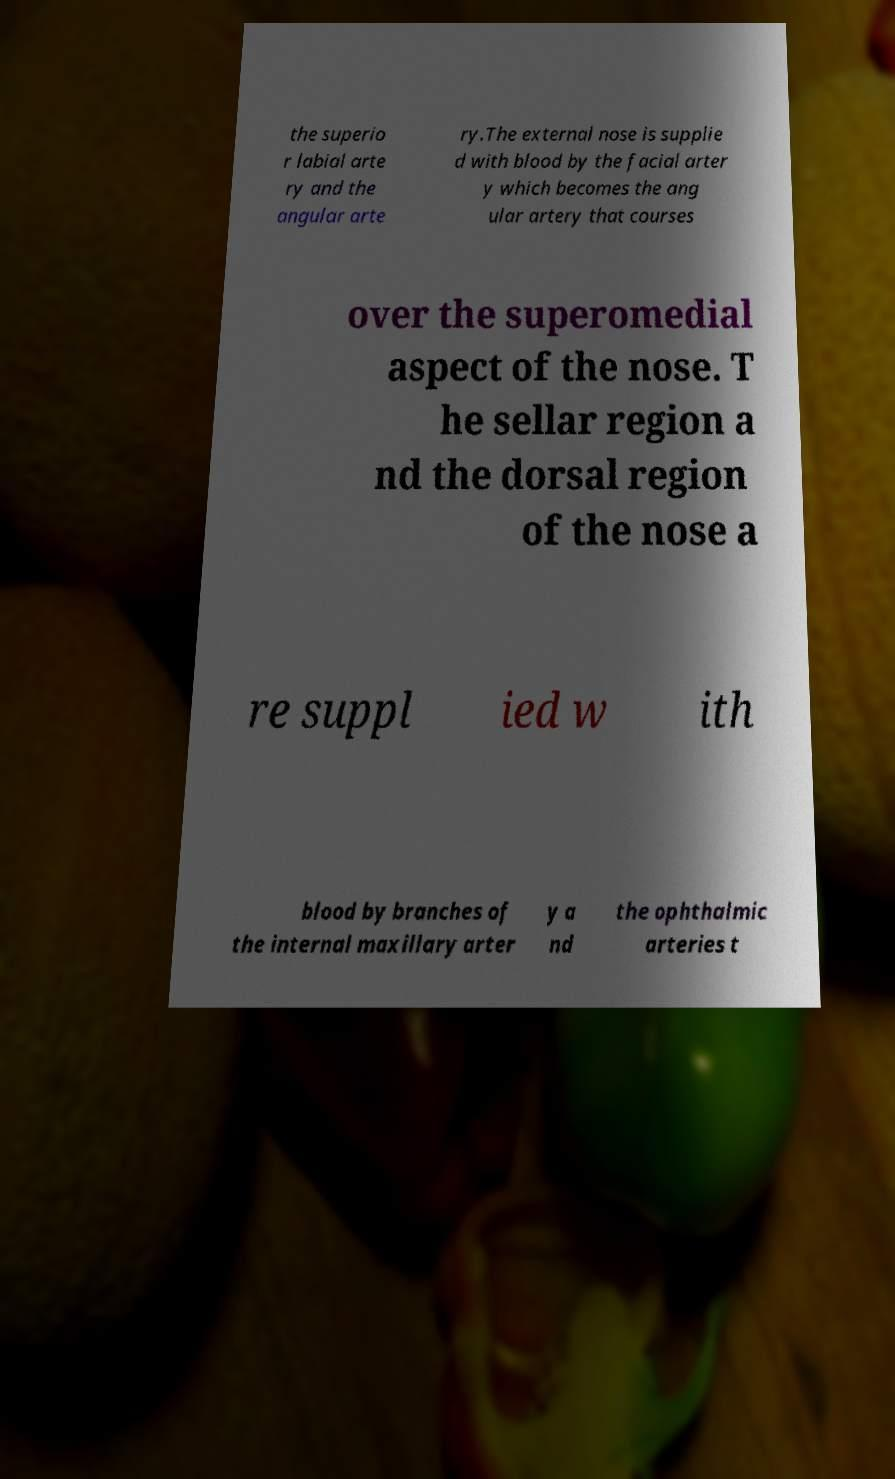There's text embedded in this image that I need extracted. Can you transcribe it verbatim? the superio r labial arte ry and the angular arte ry.The external nose is supplie d with blood by the facial arter y which becomes the ang ular artery that courses over the superomedial aspect of the nose. T he sellar region a nd the dorsal region of the nose a re suppl ied w ith blood by branches of the internal maxillary arter y a nd the ophthalmic arteries t 